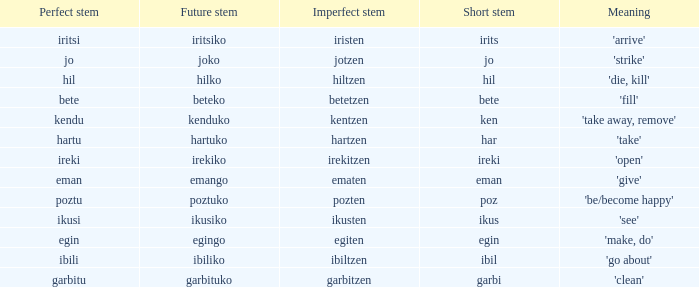Name the perfect stem for jo 1.0. 